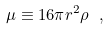<formula> <loc_0><loc_0><loc_500><loc_500>\mu \equiv 1 6 \pi r ^ { 2 } \rho \ ,</formula> 